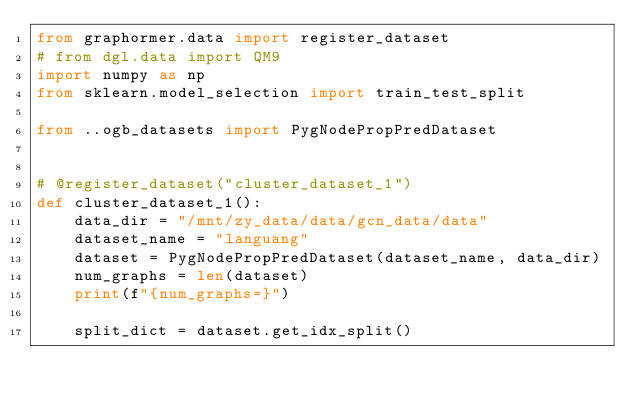<code> <loc_0><loc_0><loc_500><loc_500><_Python_>from graphormer.data import register_dataset
# from dgl.data import QM9
import numpy as np
from sklearn.model_selection import train_test_split

from ..ogb_datasets import PygNodePropPredDataset


# @register_dataset("cluster_dataset_1")
def cluster_dataset_1():
    data_dir = "/mnt/zy_data/data/gcn_data/data"
    dataset_name = "languang"
    dataset = PygNodePropPredDataset(dataset_name, data_dir)
    num_graphs = len(dataset)
    print(f"{num_graphs=}")

    split_dict = dataset.get_idx_split()</code> 